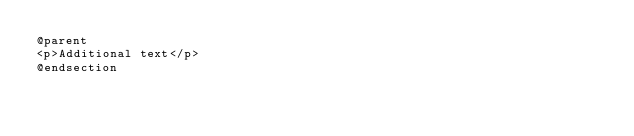<code> <loc_0><loc_0><loc_500><loc_500><_PHP_>@parent
<p>Additional text</p>
@endsection</code> 